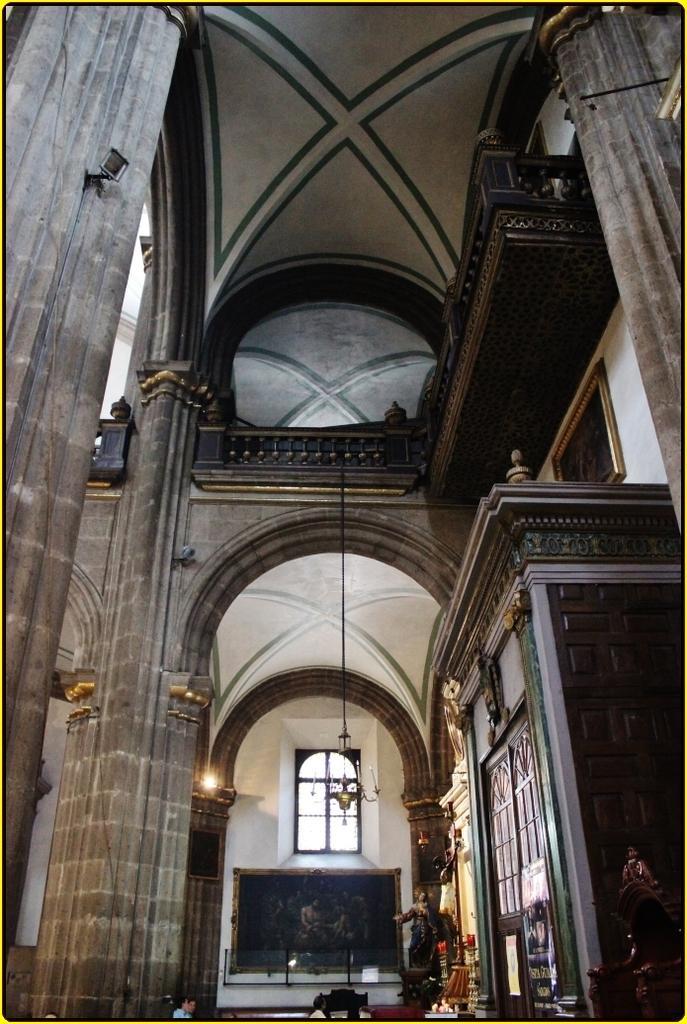Could you give a brief overview of what you see in this image? This picture is of inside. On the right there is a cabinet and a picture frame hanging on the wall. In the background we can see the wall with the arch and pillars and we can see the window and chandelier and some items placed on the right side. 